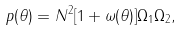<formula> <loc_0><loc_0><loc_500><loc_500>p ( \theta ) = N ^ { 2 } [ 1 + \omega ( \theta ) ] \Omega _ { 1 } \Omega _ { 2 } ,</formula> 